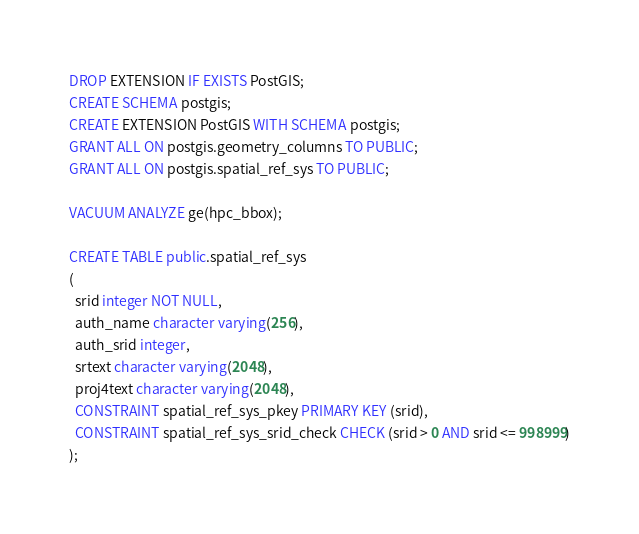<code> <loc_0><loc_0><loc_500><loc_500><_SQL_>DROP EXTENSION IF EXISTS PostGIS;
CREATE SCHEMA postgis;
CREATE EXTENSION PostGIS WITH SCHEMA postgis;
GRANT ALL ON postgis.geometry_columns TO PUBLIC;
GRANT ALL ON postgis.spatial_ref_sys TO PUBLIC;

VACUUM ANALYZE ge(hpc_bbox);

CREATE TABLE public.spatial_ref_sys
(
  srid integer NOT NULL,
  auth_name character varying(256),
  auth_srid integer,
  srtext character varying(2048),
  proj4text character varying(2048),
  CONSTRAINT spatial_ref_sys_pkey PRIMARY KEY (srid),
  CONSTRAINT spatial_ref_sys_srid_check CHECK (srid > 0 AND srid <= 998999)
);</code> 